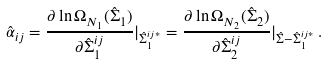Convert formula to latex. <formula><loc_0><loc_0><loc_500><loc_500>\hat { \alpha } _ { i j } = \frac { \partial \ln \Omega _ { N _ { 1 } } ( \hat { \Sigma } _ { 1 } ) } { \partial \hat { \Sigma } _ { 1 } ^ { i j } } | _ { \hat { \Sigma } _ { 1 } ^ { i j * } } = \frac { \partial \ln \Omega _ { N _ { 2 } } ( \hat { \Sigma } _ { 2 } ) } { \partial \hat { \Sigma } _ { 2 } ^ { i j } } | _ { \hat { \Sigma } - \hat { \Sigma } _ { 1 } ^ { i j * } } \, .</formula> 